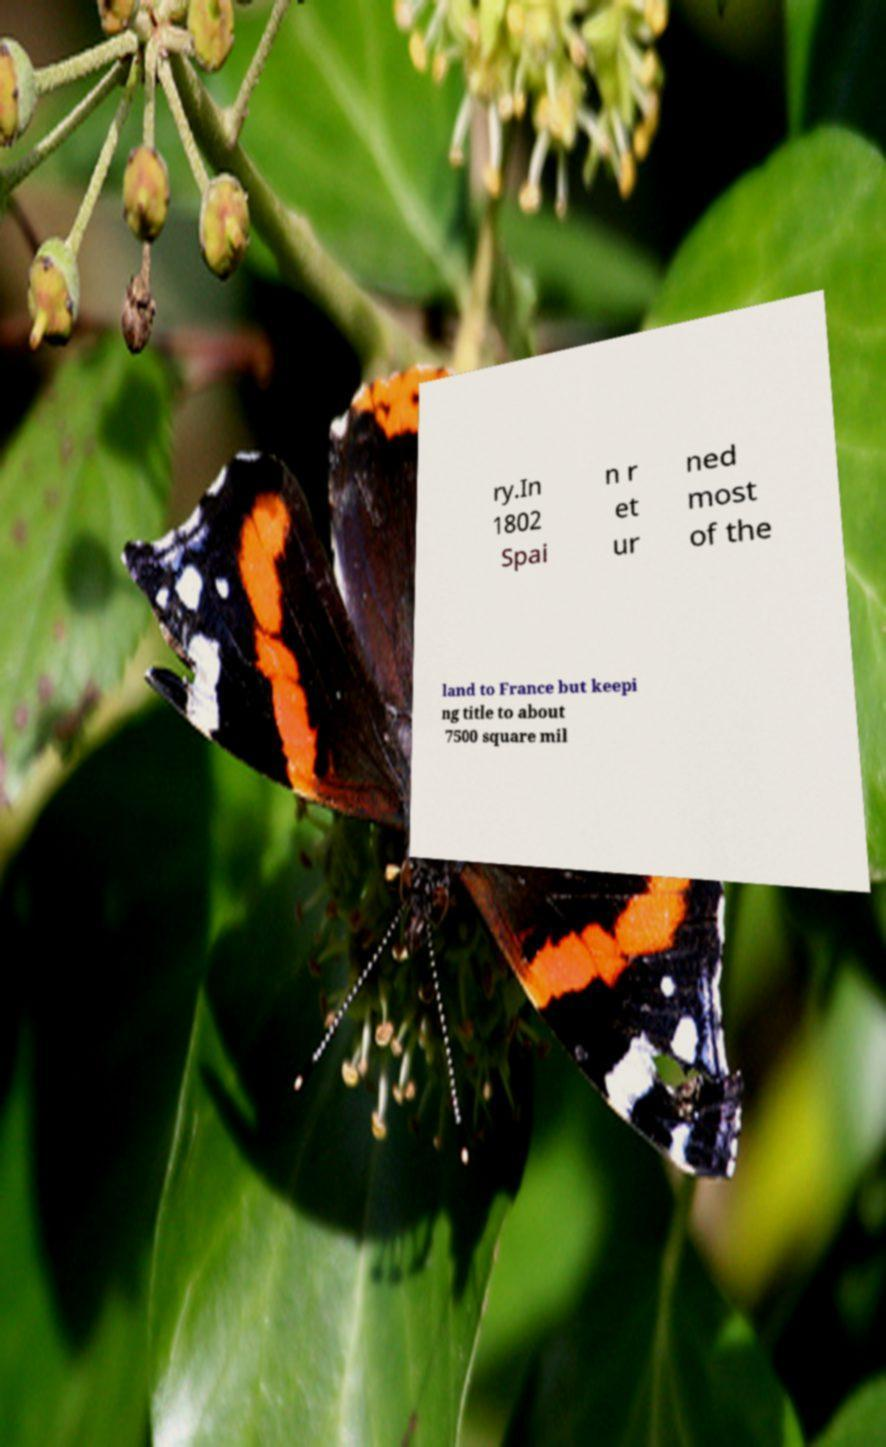There's text embedded in this image that I need extracted. Can you transcribe it verbatim? ry.In 1802 Spai n r et ur ned most of the land to France but keepi ng title to about 7500 square mil 